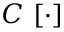<formula> <loc_0><loc_0><loc_500><loc_500>C \ [ \cdot ]</formula> 